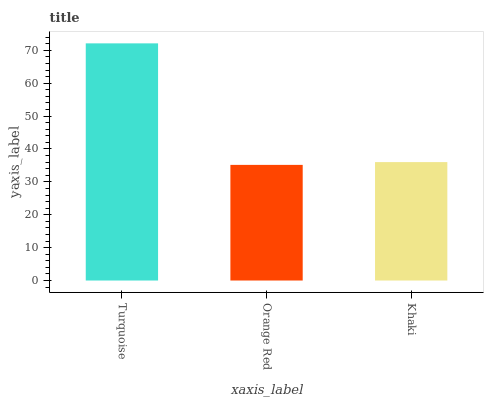Is Orange Red the minimum?
Answer yes or no. Yes. Is Turquoise the maximum?
Answer yes or no. Yes. Is Khaki the minimum?
Answer yes or no. No. Is Khaki the maximum?
Answer yes or no. No. Is Khaki greater than Orange Red?
Answer yes or no. Yes. Is Orange Red less than Khaki?
Answer yes or no. Yes. Is Orange Red greater than Khaki?
Answer yes or no. No. Is Khaki less than Orange Red?
Answer yes or no. No. Is Khaki the high median?
Answer yes or no. Yes. Is Khaki the low median?
Answer yes or no. Yes. Is Orange Red the high median?
Answer yes or no. No. Is Turquoise the low median?
Answer yes or no. No. 